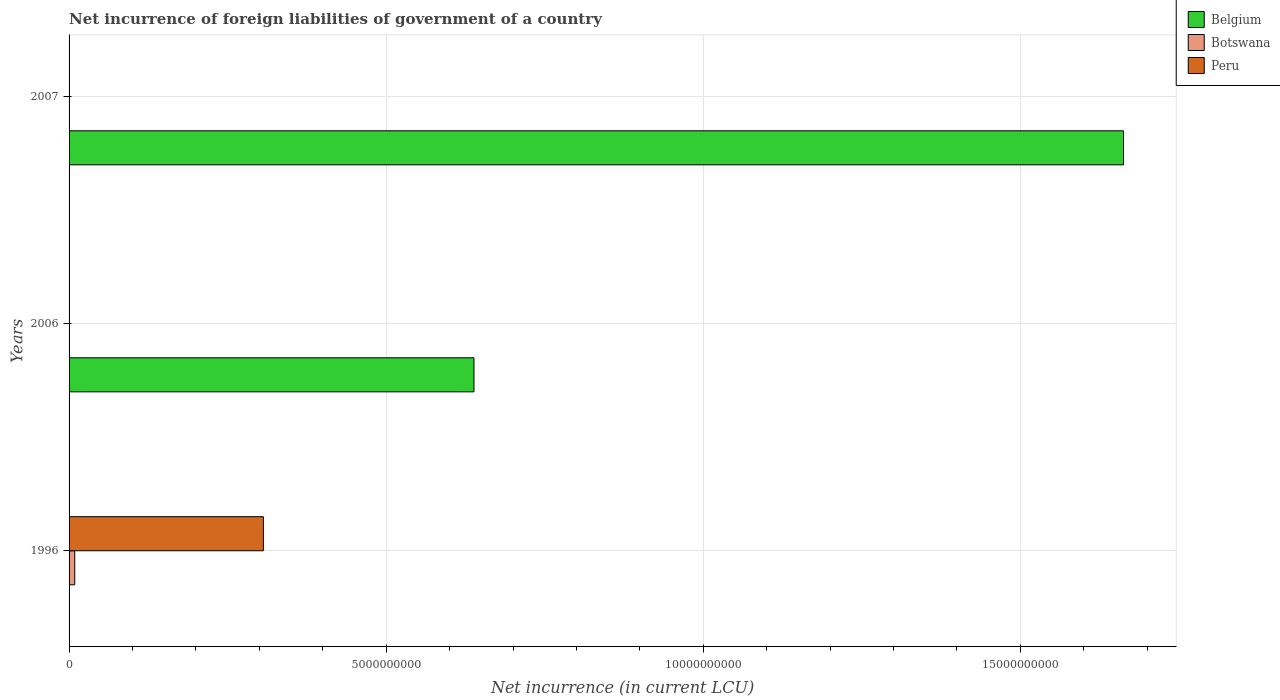How many different coloured bars are there?
Offer a very short reply. 3. Are the number of bars per tick equal to the number of legend labels?
Offer a terse response. No. In how many cases, is the number of bars for a given year not equal to the number of legend labels?
Give a very brief answer. 3. Across all years, what is the maximum net incurrence of foreign liabilities in Belgium?
Your response must be concise. 1.66e+1. Across all years, what is the minimum net incurrence of foreign liabilities in Belgium?
Offer a very short reply. 0. What is the total net incurrence of foreign liabilities in Botswana in the graph?
Give a very brief answer. 8.96e+07. What is the difference between the net incurrence of foreign liabilities in Belgium in 2006 and that in 2007?
Your answer should be very brief. -1.02e+1. What is the difference between the net incurrence of foreign liabilities in Botswana in 2006 and the net incurrence of foreign liabilities in Peru in 1996?
Keep it short and to the point. -3.06e+09. What is the average net incurrence of foreign liabilities in Botswana per year?
Your answer should be compact. 2.99e+07. In the year 1996, what is the difference between the net incurrence of foreign liabilities in Peru and net incurrence of foreign liabilities in Botswana?
Your answer should be compact. 2.97e+09. In how many years, is the net incurrence of foreign liabilities in Belgium greater than 8000000000 LCU?
Make the answer very short. 1. What is the ratio of the net incurrence of foreign liabilities in Belgium in 2006 to that in 2007?
Offer a terse response. 0.38. What is the difference between the highest and the lowest net incurrence of foreign liabilities in Botswana?
Your response must be concise. 8.96e+07. How many bars are there?
Give a very brief answer. 4. Are all the bars in the graph horizontal?
Keep it short and to the point. Yes. Are the values on the major ticks of X-axis written in scientific E-notation?
Offer a very short reply. No. Does the graph contain grids?
Your answer should be compact. Yes. How are the legend labels stacked?
Provide a short and direct response. Vertical. What is the title of the graph?
Your response must be concise. Net incurrence of foreign liabilities of government of a country. Does "Turkmenistan" appear as one of the legend labels in the graph?
Ensure brevity in your answer.  No. What is the label or title of the X-axis?
Keep it short and to the point. Net incurrence (in current LCU). What is the label or title of the Y-axis?
Ensure brevity in your answer.  Years. What is the Net incurrence (in current LCU) in Botswana in 1996?
Make the answer very short. 8.96e+07. What is the Net incurrence (in current LCU) in Peru in 1996?
Give a very brief answer. 3.06e+09. What is the Net incurrence (in current LCU) of Belgium in 2006?
Make the answer very short. 6.38e+09. What is the Net incurrence (in current LCU) in Belgium in 2007?
Make the answer very short. 1.66e+1. What is the Net incurrence (in current LCU) in Peru in 2007?
Ensure brevity in your answer.  0. Across all years, what is the maximum Net incurrence (in current LCU) of Belgium?
Offer a terse response. 1.66e+1. Across all years, what is the maximum Net incurrence (in current LCU) in Botswana?
Offer a terse response. 8.96e+07. Across all years, what is the maximum Net incurrence (in current LCU) of Peru?
Provide a succinct answer. 3.06e+09. Across all years, what is the minimum Net incurrence (in current LCU) in Peru?
Keep it short and to the point. 0. What is the total Net incurrence (in current LCU) in Belgium in the graph?
Offer a very short reply. 2.30e+1. What is the total Net incurrence (in current LCU) of Botswana in the graph?
Your response must be concise. 8.96e+07. What is the total Net incurrence (in current LCU) of Peru in the graph?
Your response must be concise. 3.06e+09. What is the difference between the Net incurrence (in current LCU) in Belgium in 2006 and that in 2007?
Provide a succinct answer. -1.02e+1. What is the average Net incurrence (in current LCU) in Belgium per year?
Give a very brief answer. 7.67e+09. What is the average Net incurrence (in current LCU) of Botswana per year?
Your answer should be compact. 2.99e+07. What is the average Net incurrence (in current LCU) of Peru per year?
Keep it short and to the point. 1.02e+09. In the year 1996, what is the difference between the Net incurrence (in current LCU) of Botswana and Net incurrence (in current LCU) of Peru?
Keep it short and to the point. -2.97e+09. What is the ratio of the Net incurrence (in current LCU) in Belgium in 2006 to that in 2007?
Your answer should be compact. 0.38. What is the difference between the highest and the lowest Net incurrence (in current LCU) of Belgium?
Your response must be concise. 1.66e+1. What is the difference between the highest and the lowest Net incurrence (in current LCU) in Botswana?
Keep it short and to the point. 8.96e+07. What is the difference between the highest and the lowest Net incurrence (in current LCU) in Peru?
Your response must be concise. 3.06e+09. 